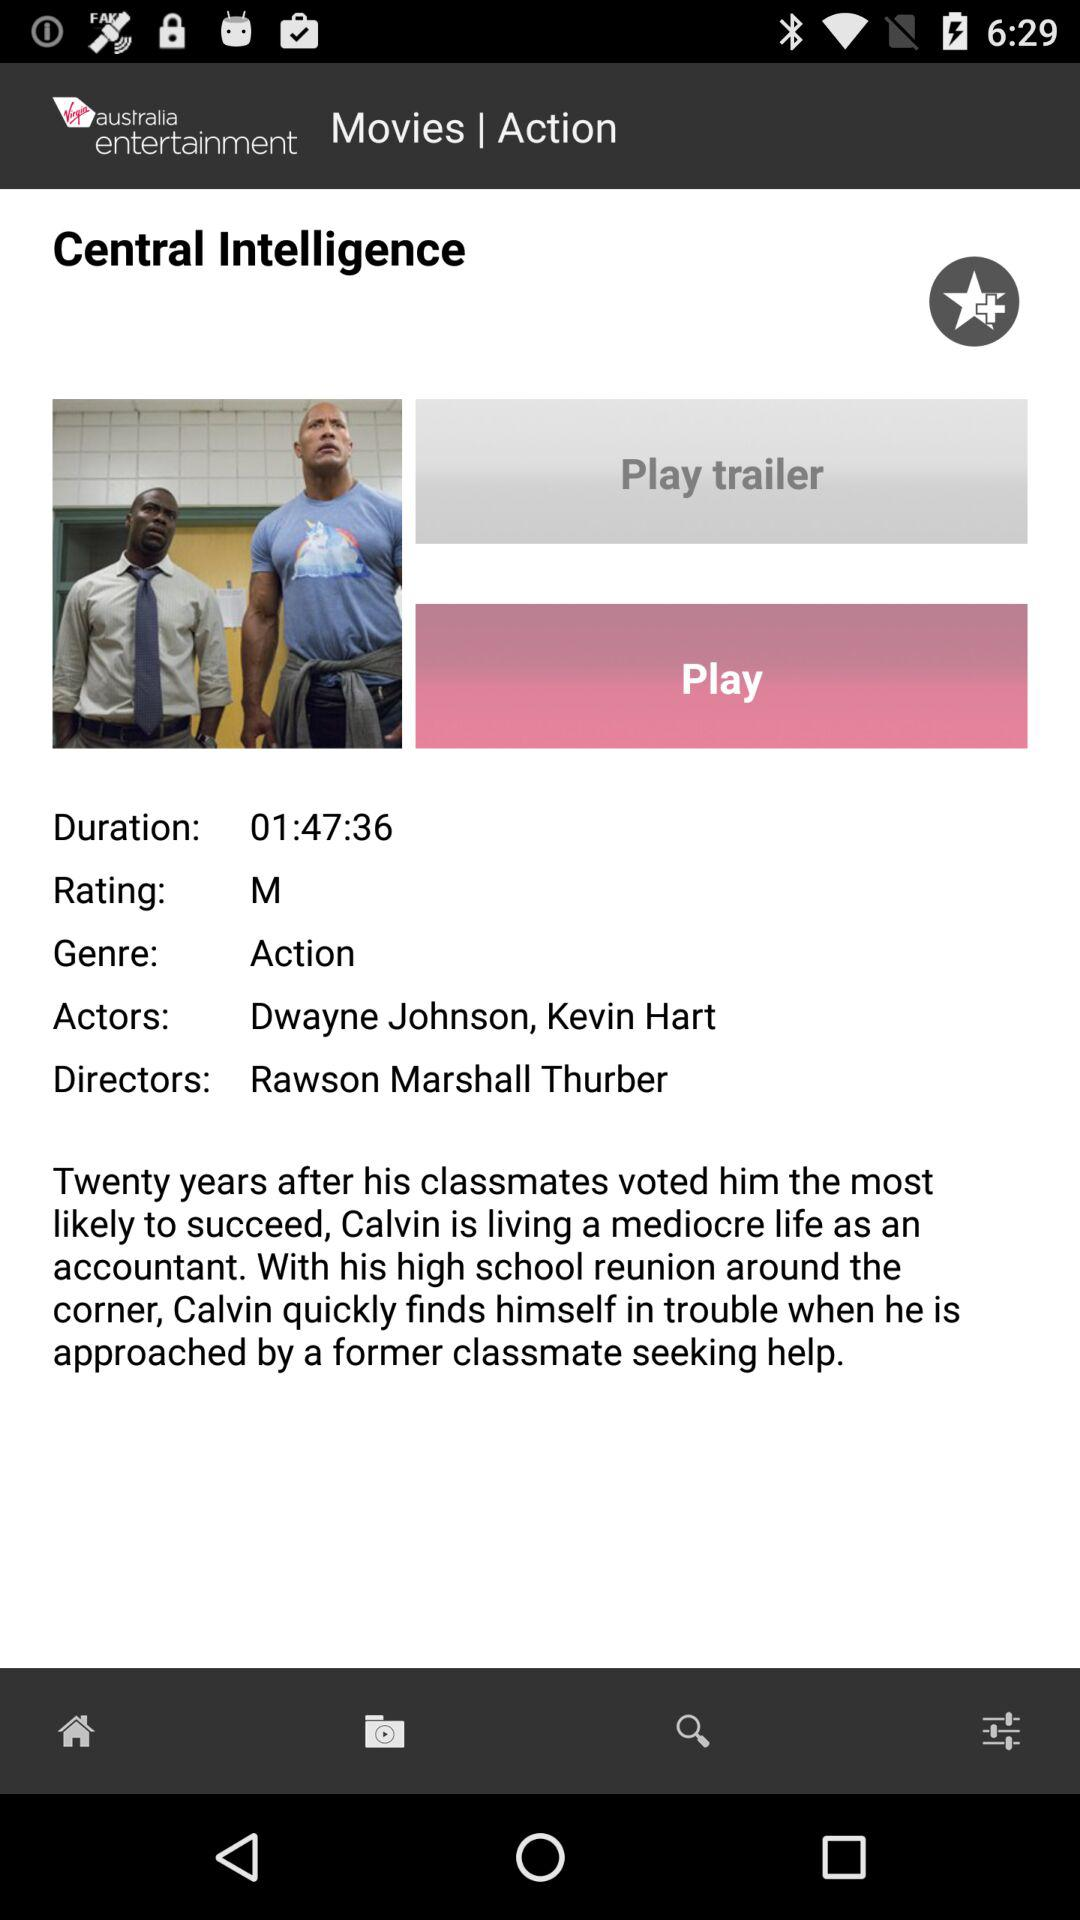What is the name of the movie? The name of the movie is "Central Intelligence". 